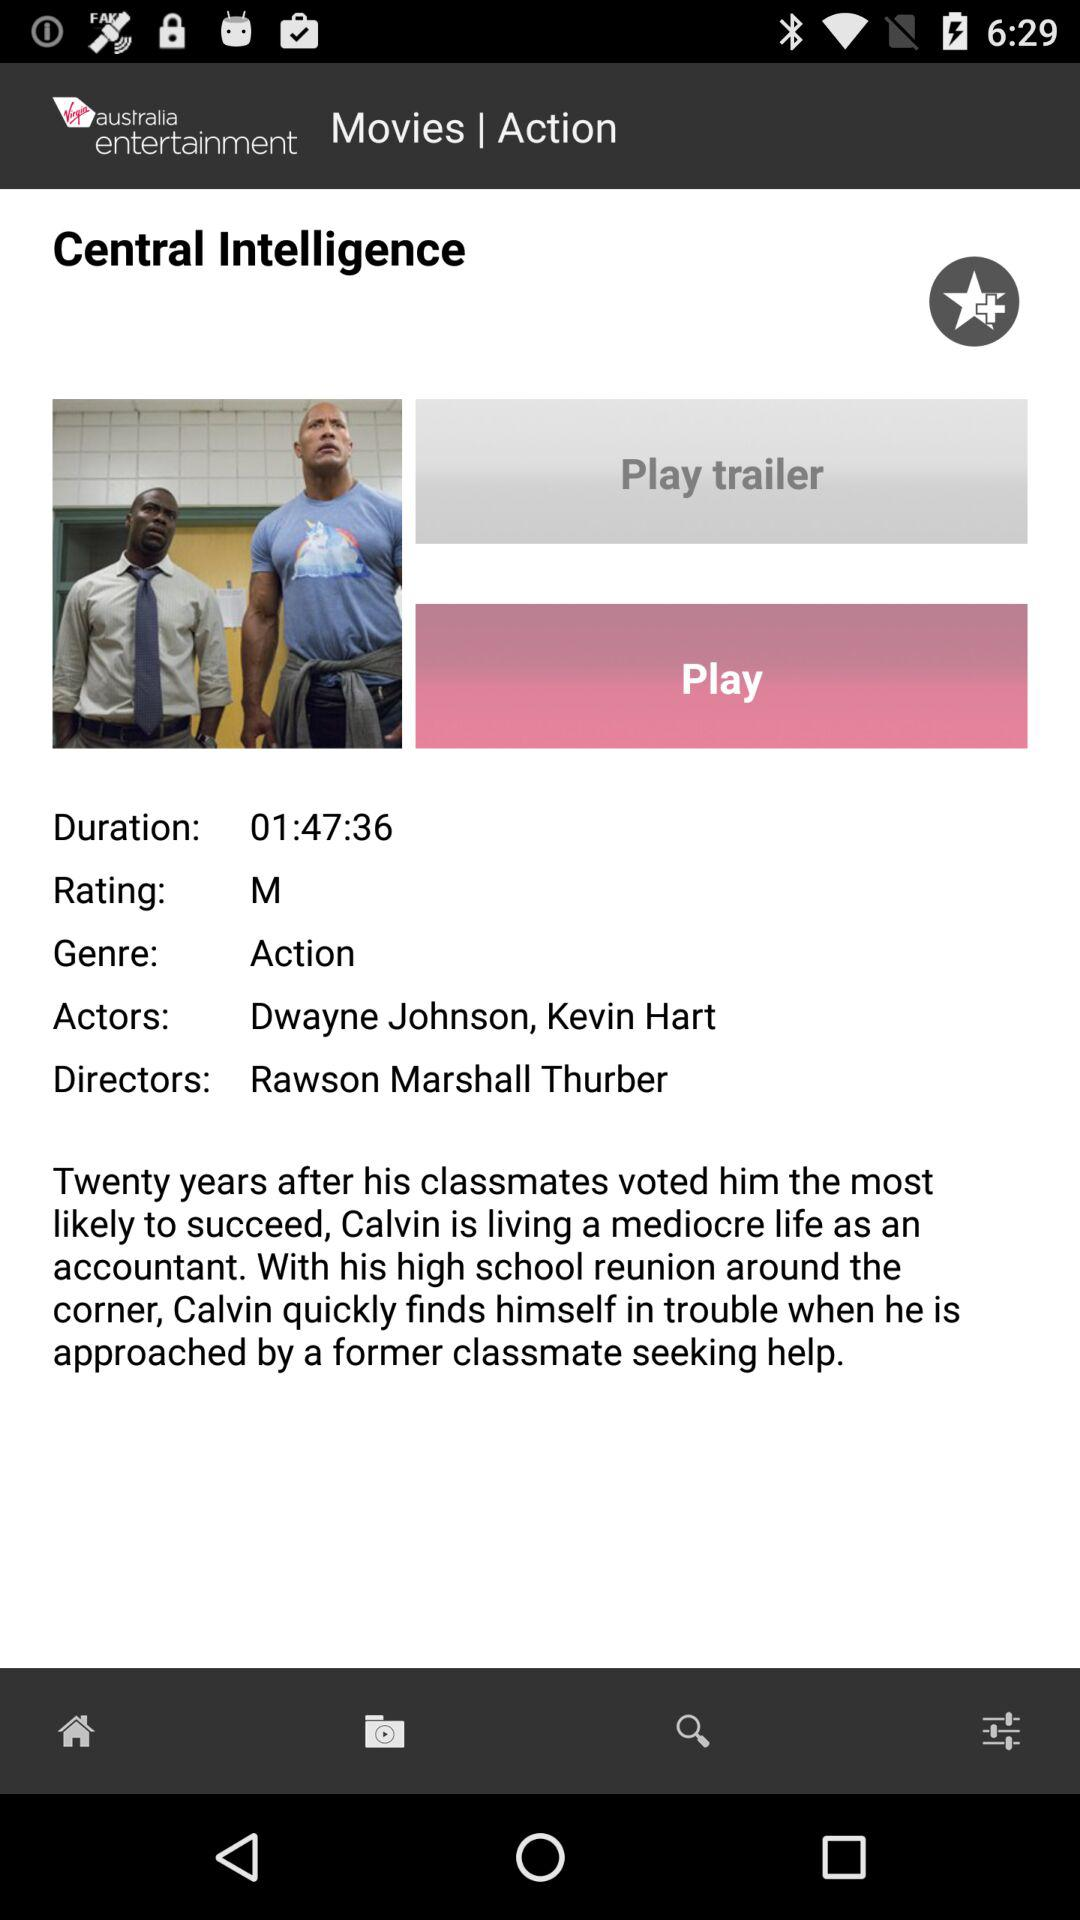What is the name of the movie? The name of the movie is "Central Intelligence". 